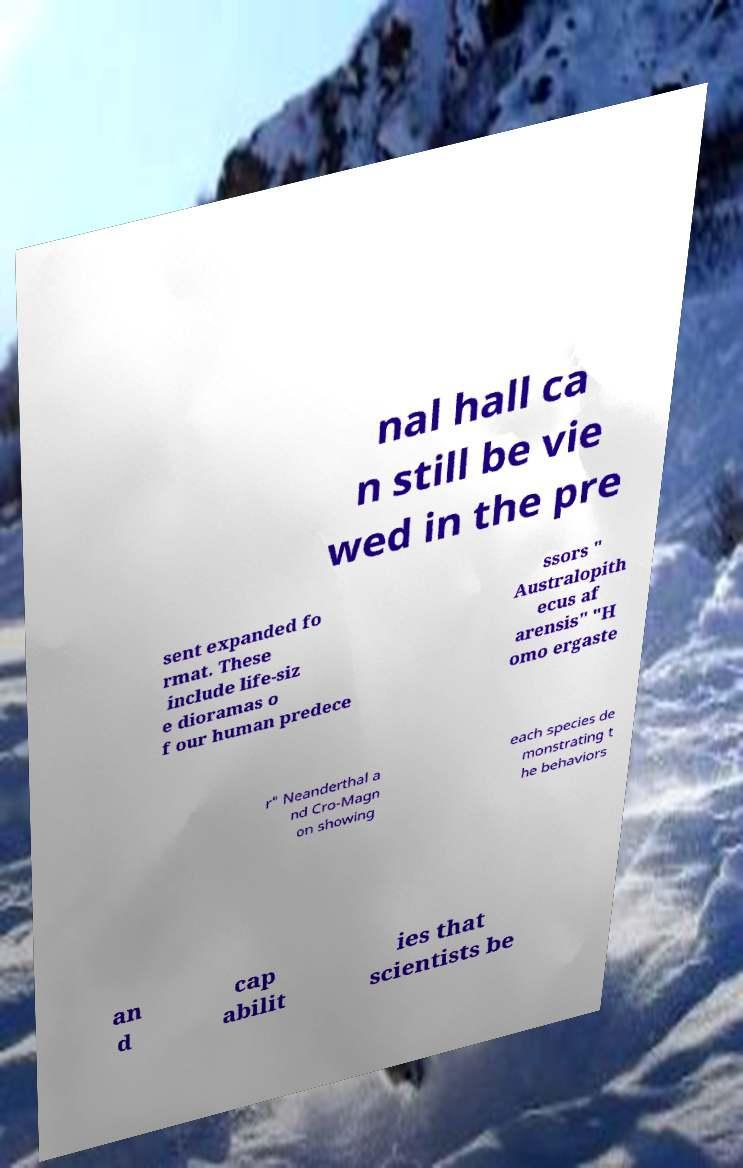Please read and relay the text visible in this image. What does it say? nal hall ca n still be vie wed in the pre sent expanded fo rmat. These include life-siz e dioramas o f our human predece ssors " Australopith ecus af arensis" "H omo ergaste r" Neanderthal a nd Cro-Magn on showing each species de monstrating t he behaviors an d cap abilit ies that scientists be 